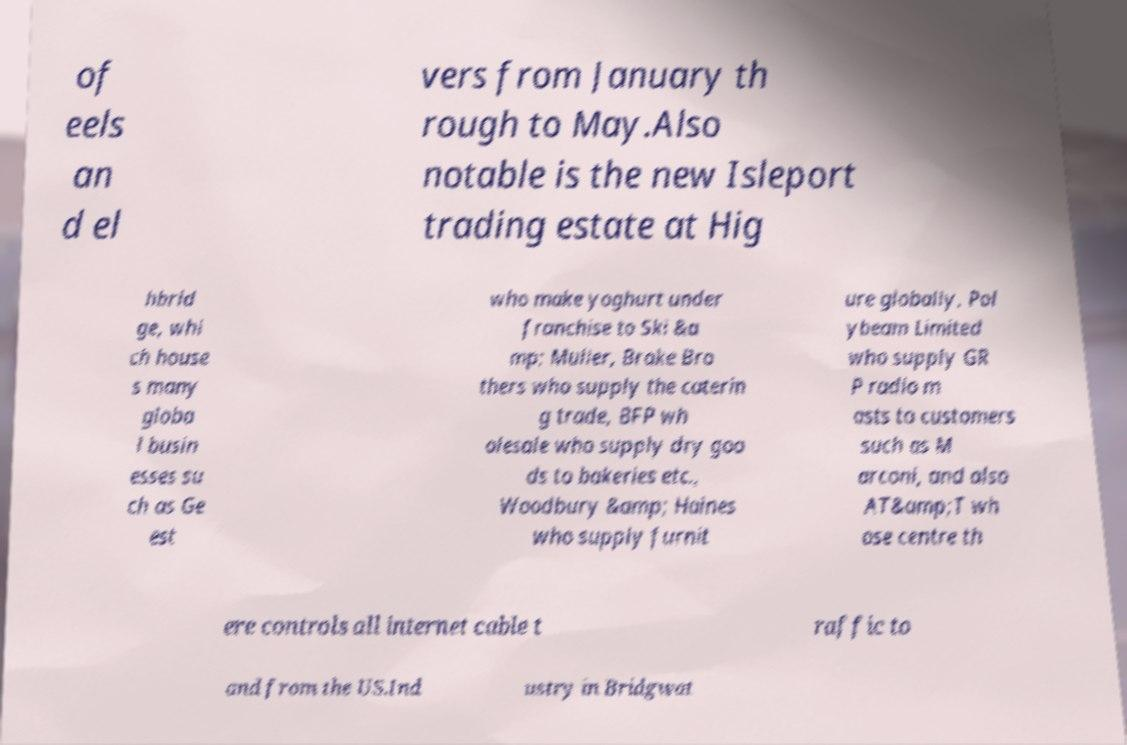Can you accurately transcribe the text from the provided image for me? of eels an d el vers from January th rough to May.Also notable is the new Isleport trading estate at Hig hbrid ge, whi ch house s many globa l busin esses su ch as Ge est who make yoghurt under franchise to Ski &a mp; Muller, Brake Bro thers who supply the caterin g trade, BFP wh olesale who supply dry goo ds to bakeries etc., Woodbury &amp; Haines who supply furnit ure globally, Pol ybeam Limited who supply GR P radio m asts to customers such as M arconi, and also AT&amp;T wh ose centre th ere controls all internet cable t raffic to and from the US.Ind ustry in Bridgwat 